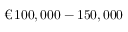<formula> <loc_0><loc_0><loc_500><loc_500>\text  euro \, 1 0 0 , 0 0 0 - 1 5 0 , 0 0 0</formula> 